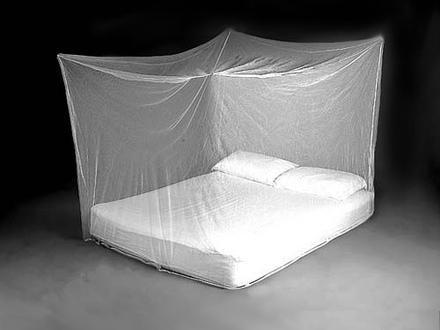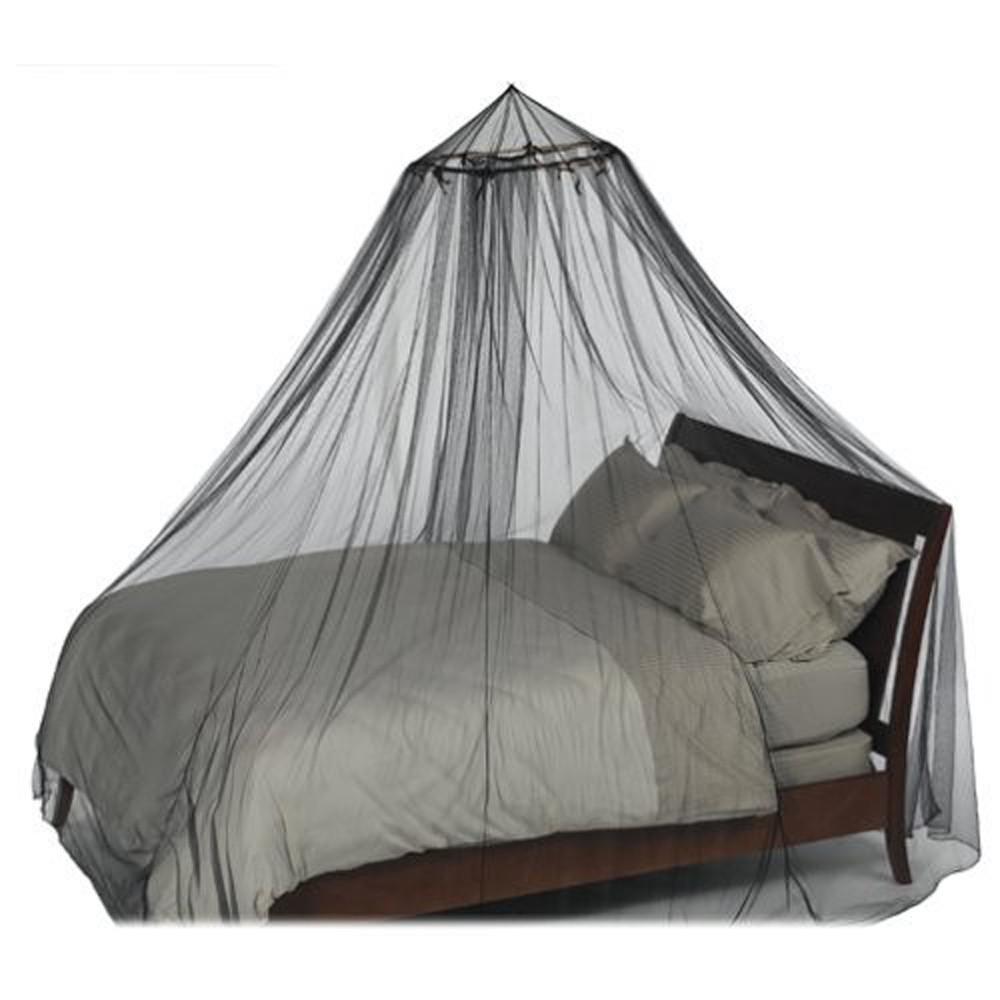The first image is the image on the left, the second image is the image on the right. Analyze the images presented: Is the assertion "In the left image, all pillows are white." valid? Answer yes or no. Yes. The first image is the image on the left, the second image is the image on the right. Examine the images to the left and right. Is the description "Exactly one net is white." accurate? Answer yes or no. Yes. 